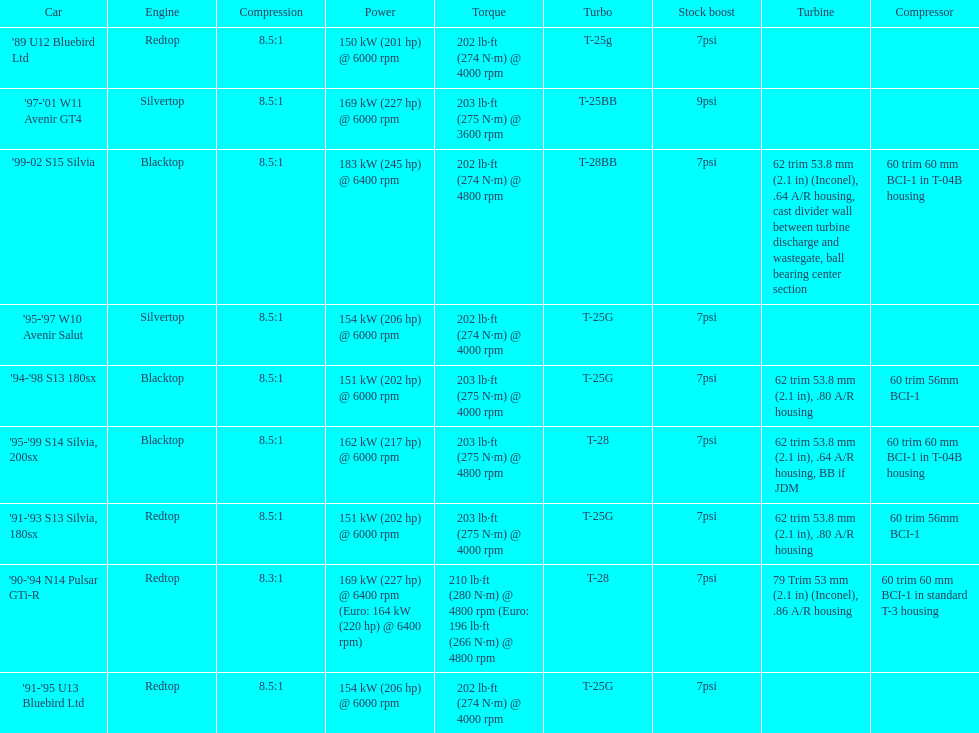What is his/her compression for the 90-94 n14 pulsar gti-r? 8.3:1. 